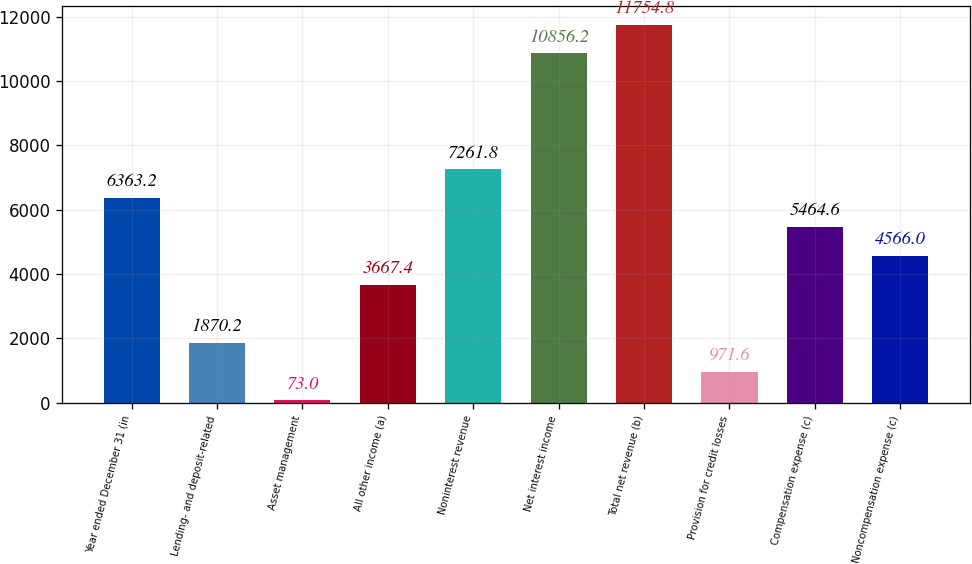Convert chart. <chart><loc_0><loc_0><loc_500><loc_500><bar_chart><fcel>Year ended December 31 (in<fcel>Lending- and deposit-related<fcel>Asset management<fcel>All other income (a)<fcel>Noninterest revenue<fcel>Net interest income<fcel>Total net revenue (b)<fcel>Provision for credit losses<fcel>Compensation expense (c)<fcel>Noncompensation expense (c)<nl><fcel>6363.2<fcel>1870.2<fcel>73<fcel>3667.4<fcel>7261.8<fcel>10856.2<fcel>11754.8<fcel>971.6<fcel>5464.6<fcel>4566<nl></chart> 